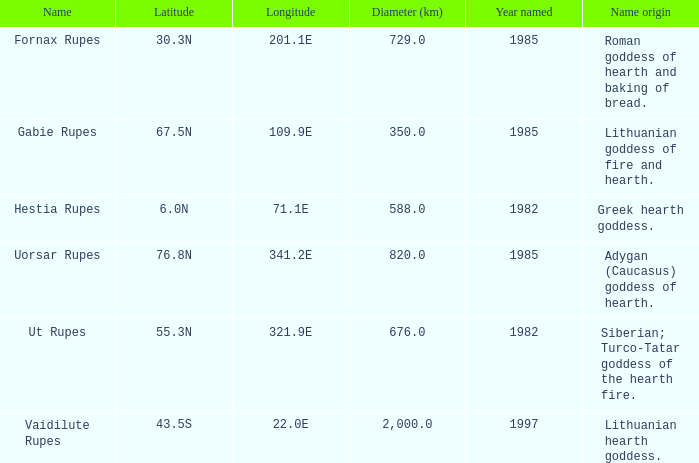Can you provide the latitude for vaidilute rupes? 43.5S. 